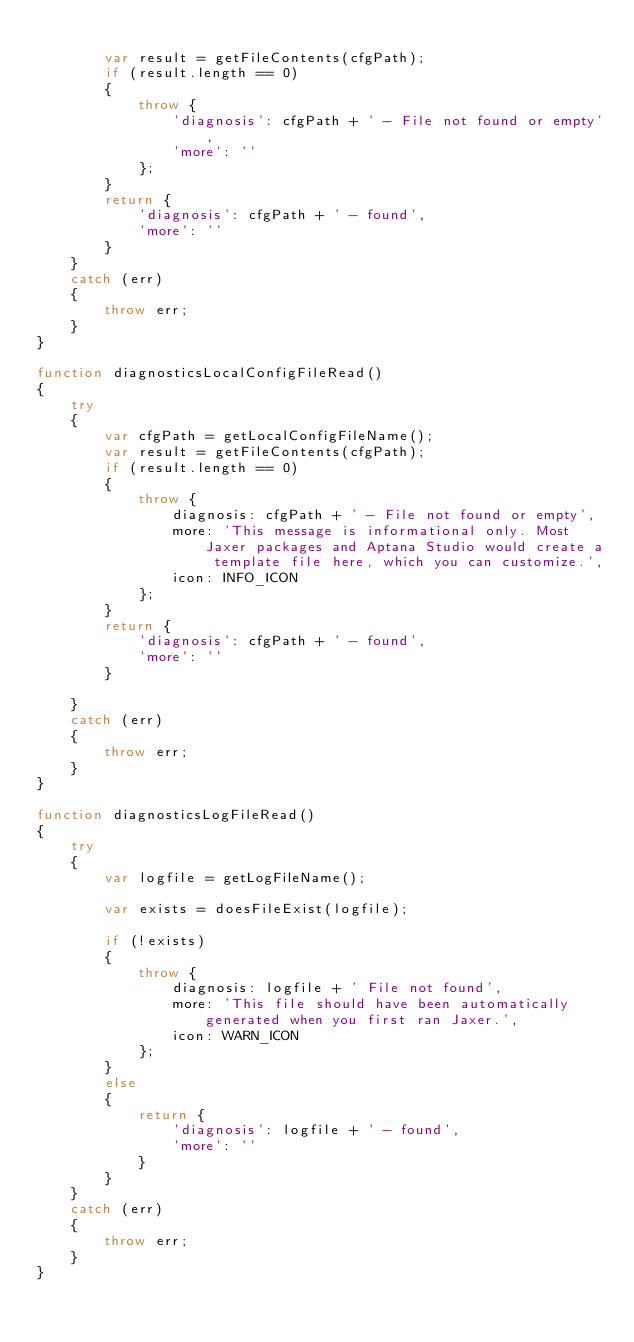<code> <loc_0><loc_0><loc_500><loc_500><_JavaScript_>		
        var result = getFileContents(cfgPath);
        if (result.length == 0) 
        {
            throw {
                'diagnosis': cfgPath + ' - File not found or empty',
                'more': ''
            };
        }
        return {
            'diagnosis': cfgPath + ' - found',
            'more': ''
        }
    } 
    catch (err) 
    {
        throw err;
    }
}

function diagnosticsLocalConfigFileRead()
{
    try 
    {
        var cfgPath = getLocalConfigFileName();
        var result = getFileContents(cfgPath);
        if (result.length == 0) 
        {
            throw {
                diagnosis: cfgPath + ' - File not found or empty',
                more: 'This message is informational only. Most Jaxer packages and Aptana Studio would create a template file here, which you can customize.',
                icon: INFO_ICON
            };
        }
        return {
            'diagnosis': cfgPath + ' - found',
            'more': ''
        }
        
    } 
    catch (err) 
    {
        throw err;
    }
}

function diagnosticsLogFileRead()
{
    try 
    {
        var logfile = getLogFileName();
        
        var exists = doesFileExist(logfile);
        
        if (!exists) 
        {
            throw {
                diagnosis: logfile + ' File not found',
                more: 'This file should have been automatically generated when you first ran Jaxer.',
                icon: WARN_ICON
            };
        }
        else 
        {
            return {
                'diagnosis': logfile + ' - found',
                'more': ''
            }
        }
    } 
    catch (err) 
    {
        throw err;
    }
}
</code> 